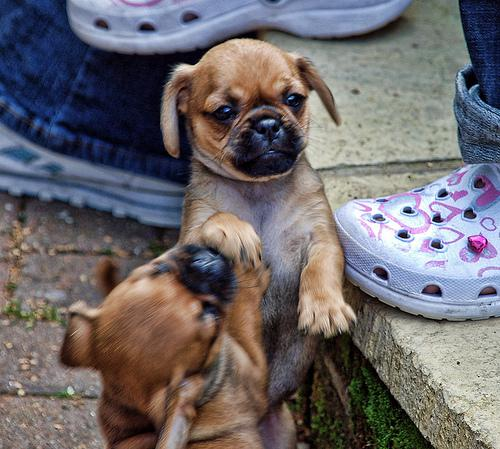Question: what color are the puppies?
Choices:
A. Blue.
B. Red.
C. Brown.
D. Brown and Black.
Answer with the letter. Answer: D Question: how many puppies are in this picture?
Choices:
A. 3.
B. 4.
C. 2.
D. 9.
Answer with the letter. Answer: C Question: where are the puppies?
Choices:
A. On the porch.
B. On the stairs.
C. On the grass.
D. On the sidewalk.
Answer with the letter. Answer: B Question: what are the puppies doing?
Choices:
A. Running.
B. Sitting.
C. Playing.
D. Jumping.
Answer with the letter. Answer: C Question: what kind of pants is the girl wearing?
Choices:
A. Jeans.
B. Slacks.
C. Khakis.
D. Cargo pants.
Answer with the letter. Answer: A 